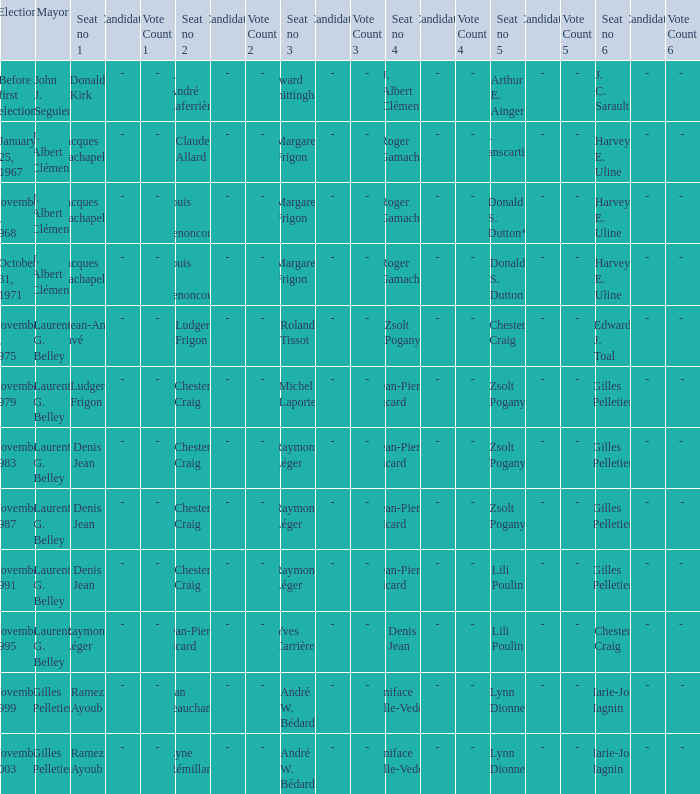Who was the winner of seat no 4 for the election on January 25, 1967 Roger Gamache. 